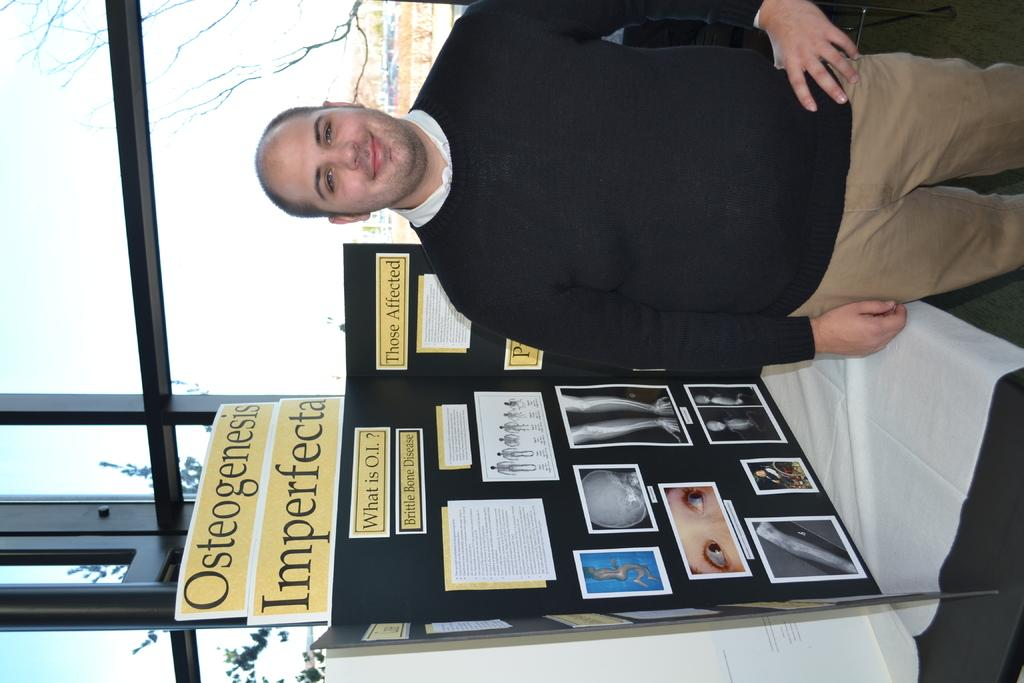<image>
Write a terse but informative summary of the picture. a man in a black sweater standing in front of a osteogenesis imperfecta project board. 